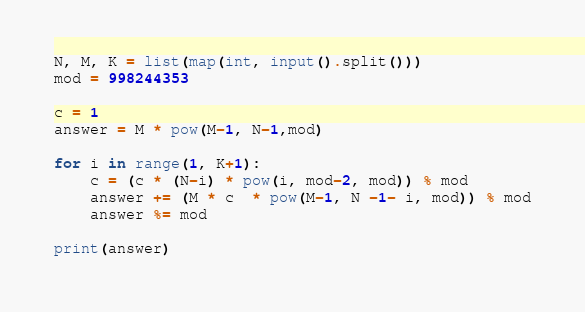Convert code to text. <code><loc_0><loc_0><loc_500><loc_500><_Python_>N, M, K = list(map(int, input().split()))
mod = 998244353

c = 1
answer = M * pow(M-1, N-1,mod)

for i in range(1, K+1):
    c = (c * (N-i) * pow(i, mod-2, mod)) % mod
    answer += (M * c  * pow(M-1, N -1- i, mod)) % mod
    answer %= mod
    
print(answer)</code> 